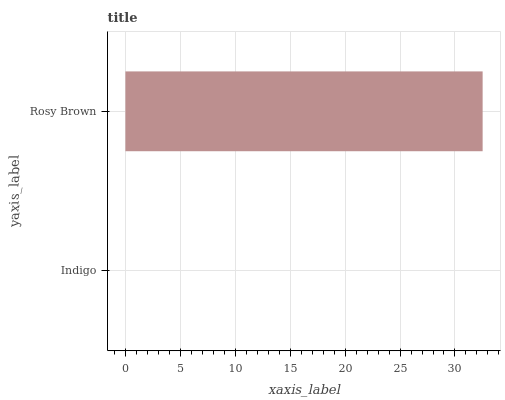Is Indigo the minimum?
Answer yes or no. Yes. Is Rosy Brown the maximum?
Answer yes or no. Yes. Is Rosy Brown the minimum?
Answer yes or no. No. Is Rosy Brown greater than Indigo?
Answer yes or no. Yes. Is Indigo less than Rosy Brown?
Answer yes or no. Yes. Is Indigo greater than Rosy Brown?
Answer yes or no. No. Is Rosy Brown less than Indigo?
Answer yes or no. No. Is Rosy Brown the high median?
Answer yes or no. Yes. Is Indigo the low median?
Answer yes or no. Yes. Is Indigo the high median?
Answer yes or no. No. Is Rosy Brown the low median?
Answer yes or no. No. 